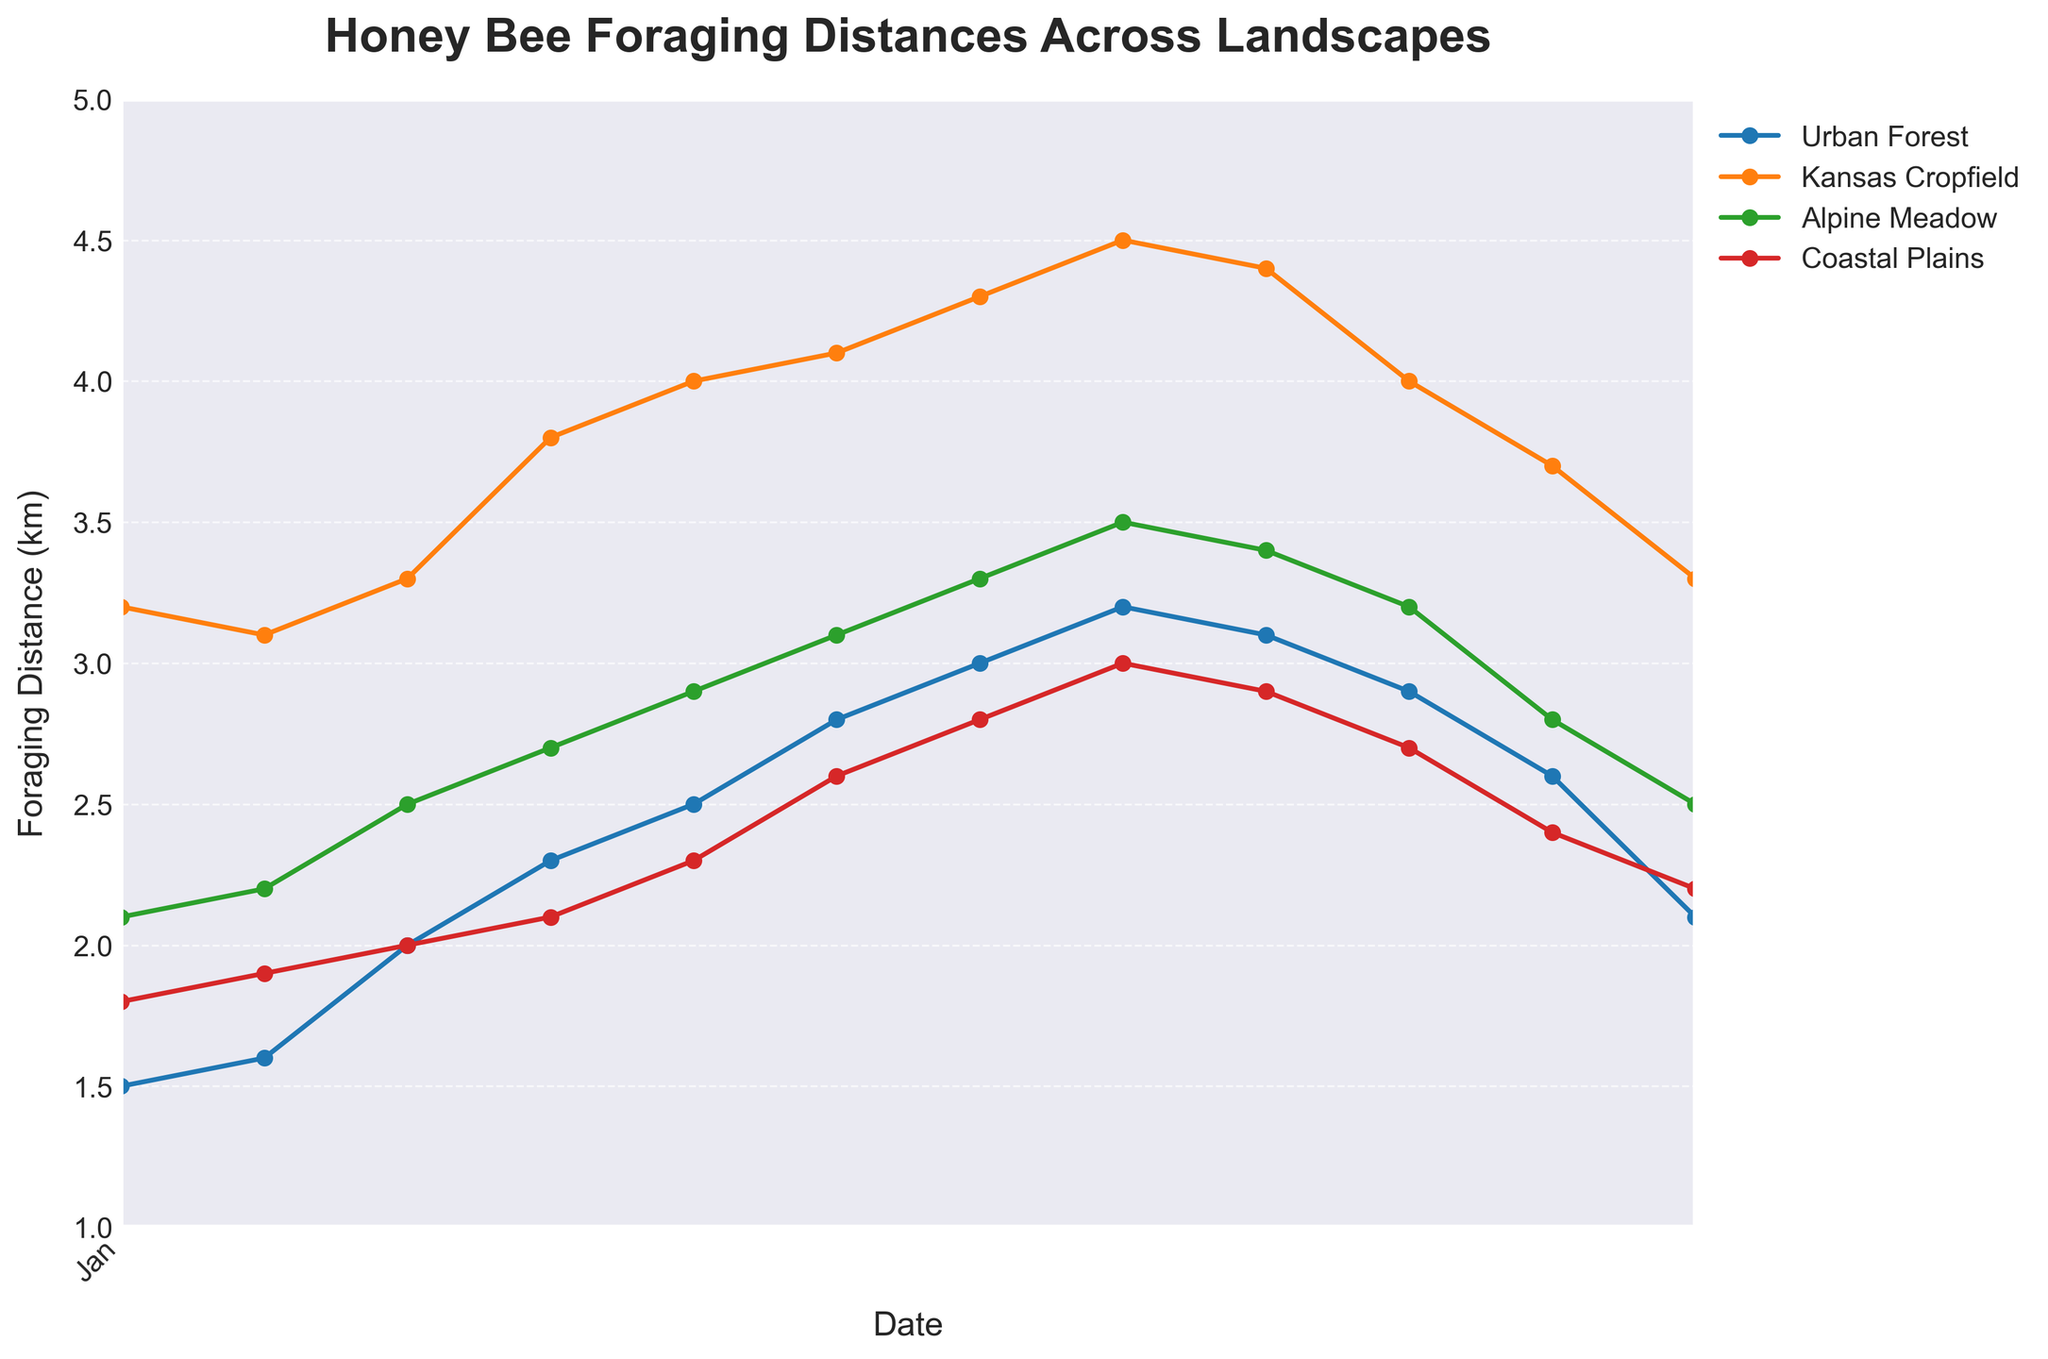what is the title of the plot? The title is typically positioned at the top center of a plot. Here, it reads "Honey Bee Foraging Distances Across Landscapes".
Answer: Honey Bee Foraging Distances Across Landscapes Which landscape shows the highest foraging distance in March? By looking at the data points for March, the landscape with the highest value is Kansas Cropfield at 3.3 km.
Answer: Kansas Cropfield What are the labels on the y-axis? The y-axis measures foraging distances, so its labels would be "Foraging Distance (km)".
Answer: Foraging Distance (km) How does the foraging distance in Urban Forest change from January to December? The foraging distance in Urban Forest starts at 1.5 km in January and rises to a peak of 3.2 km in August before decreasing to 2.1 km in December.
Answer: 1.5 km in January to 2.1 km in December Compare the foraging distances between Coastal Plains and Alpine Meadow in July. Which is greater? Coastal Plains have a distance of 2.8 km, whereas Alpine Meadow has a distance of 3.3 km in July. Alpine Meadow has a greater distance.
Answer: Alpine Meadow Which month shows the maximum average foraging distance across all landscapes? To find the maximum average, sum the foraging distances for all landscapes for each month and identify the month with the highest average. August has the highest average with total (3.2 + 4.5 + 3.5 + 3.0)/4 = 3.55 km.
Answer: August What's the difference in foraging distance between Kansas Cropfield and Coastal Plains in May? Subtract the distance of Coastal Plains from Kansas Cropfield in May: 4.0 km - 2.3 km = 1.7 km.
Answer: 1.7 km Which month shows the smallest foraging range (difference between maximum and minimum values) across landscapes? For each month, calculate the difference between the maximum and minimum values across landscapes. January has the smallest foraging range: 3.2 km - 1.5 km = 1.7 km.
Answer: January Identify a month when all foraging distances show an increasing trend compared to the previous month. April shows an increasing trend across all landscapes compared to March: Urban Forest (2.3 > 2.0), Kansas Cropfield (3.8 > 3.3), Alpine Meadow (2.7 > 2.5), Coastal Plains (2.1 > 2.0).
Answer: April 